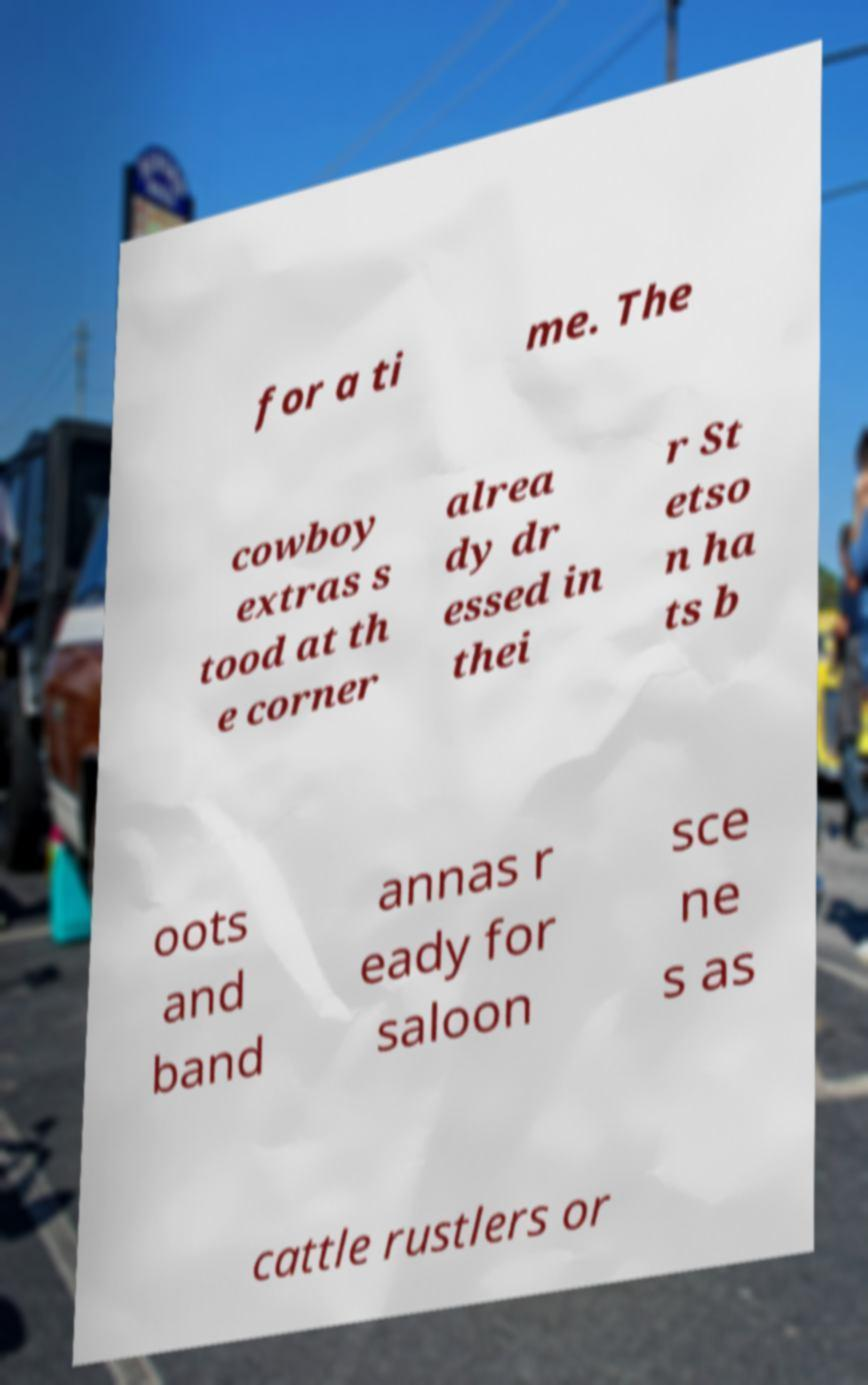I need the written content from this picture converted into text. Can you do that? for a ti me. The cowboy extras s tood at th e corner alrea dy dr essed in thei r St etso n ha ts b oots and band annas r eady for saloon sce ne s as cattle rustlers or 